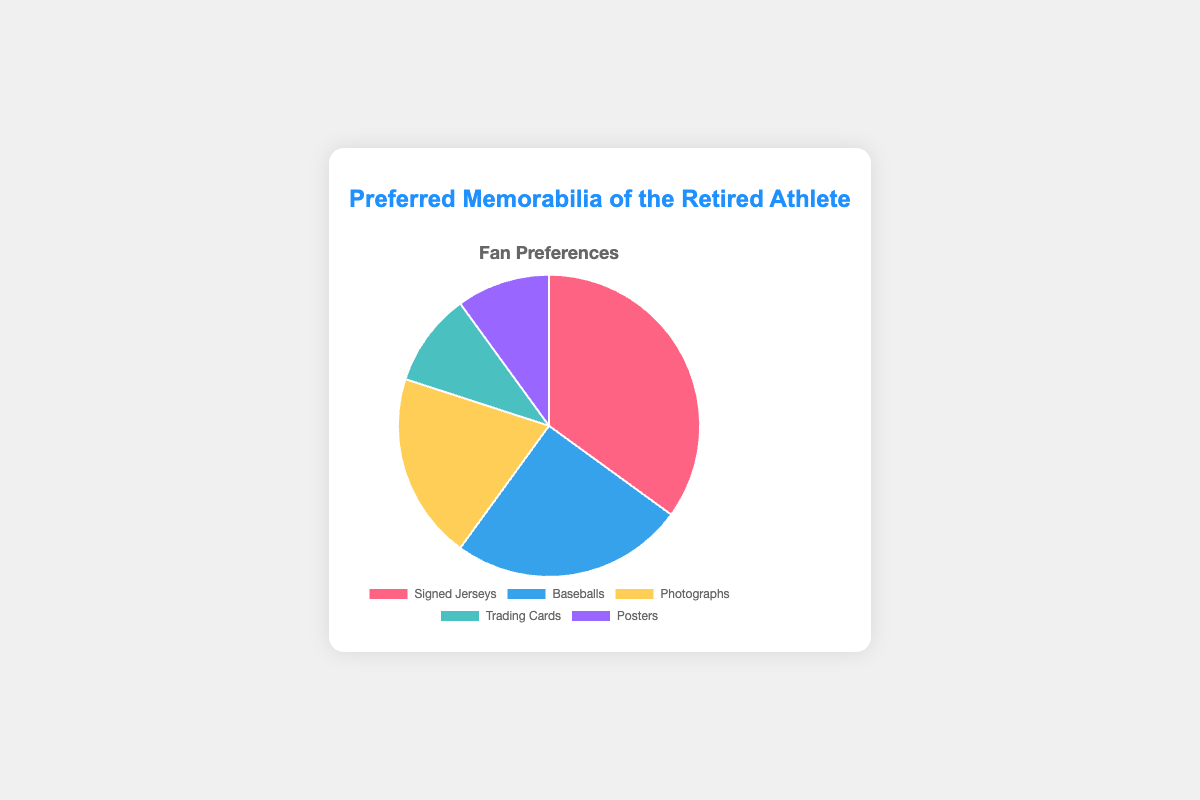Which type of memorabilia has the highest preference? Signed Jerseys have the highest preference at 35%, as seen from the largest portion of the pie chart.
Answer: Signed Jerseys What is the combined percentage of the least preferred types of memorabilia? The least preferred types, Trading Cards and Posters, each have 10%. Adding these gives 10% + 10% = 20%.
Answer: 20% How much more preferred are signed jerseys compared to trading cards? Signed Jerseys are 35% and Trading Cards are 10%, so the difference is 35% - 10% = 25%.
Answer: 25% Which memorabilia come next in preference after signed jerseys? Baseballs are next in preference with 25%, as shown by the second largest portion of the pie chart.
Answer: Baseballs Is the preference for photographs higher than the preference for posters? Yes, Photographs have 20% preference while Posters have 10%, making Photographs more preferred.
Answer: Yes Which color represents the preference for baseballs? The color representing Baseballs is the second slice from the top, typically shown in blue in the chart.
Answer: Blue What is the average percentage preference across all types of memorabilia? To find the average, sum up all percentages (35 + 25 + 20 + 10 + 10 = 100) and divide by the number of types (5). The average is 100/5 = 20%.
Answer: 20% Which two types of memorabilia have equal preference percentages? Trading Cards and Posters both have a preference percentage of 10%.
Answer: Trading Cards and Posters Is the preference for baseballs closer to that of signed jerseys or photographs? The preference for Baseballs (25%) is closer to that of Signed Jerseys (35%) than Photographs (20%), since 25% is 10% away from 35% and 5% away from 20%.
Answer: Photographs What share of the total does the preference for signed jerseys and baseballs comprise? Adding the percentages for Signed Jerseys (35%) and Baseballs (25%) yields 35% + 25% = 60%.
Answer: 60% 